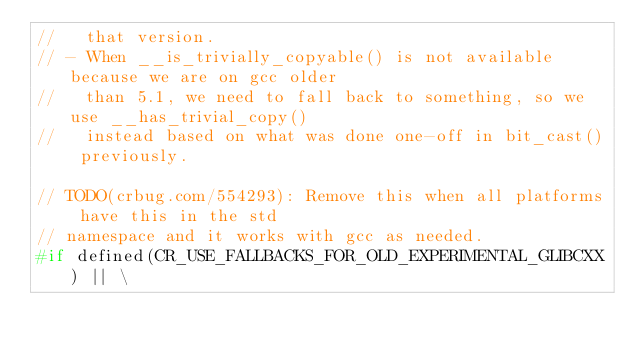Convert code to text. <code><loc_0><loc_0><loc_500><loc_500><_C_>//   that version.
// - When __is_trivially_copyable() is not available because we are on gcc older
//   than 5.1, we need to fall back to something, so we use __has_trivial_copy()
//   instead based on what was done one-off in bit_cast() previously.

// TODO(crbug.com/554293): Remove this when all platforms have this in the std
// namespace and it works with gcc as needed.
#if defined(CR_USE_FALLBACKS_FOR_OLD_EXPERIMENTAL_GLIBCXX) || \</code> 